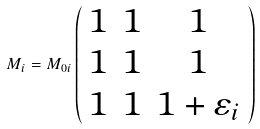Convert formula to latex. <formula><loc_0><loc_0><loc_500><loc_500>M _ { i } = M _ { 0 i } \left ( \begin{array} { c c c } 1 & 1 & 1 \\ 1 & 1 & 1 \\ 1 & 1 & 1 + \varepsilon _ { i } \end{array} \right )</formula> 